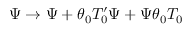<formula> <loc_0><loc_0><loc_500><loc_500>\Psi \rightarrow \Psi + \theta _ { 0 } T _ { 0 } ^ { \prime } \Psi + \Psi \theta _ { 0 } T _ { 0 }</formula> 